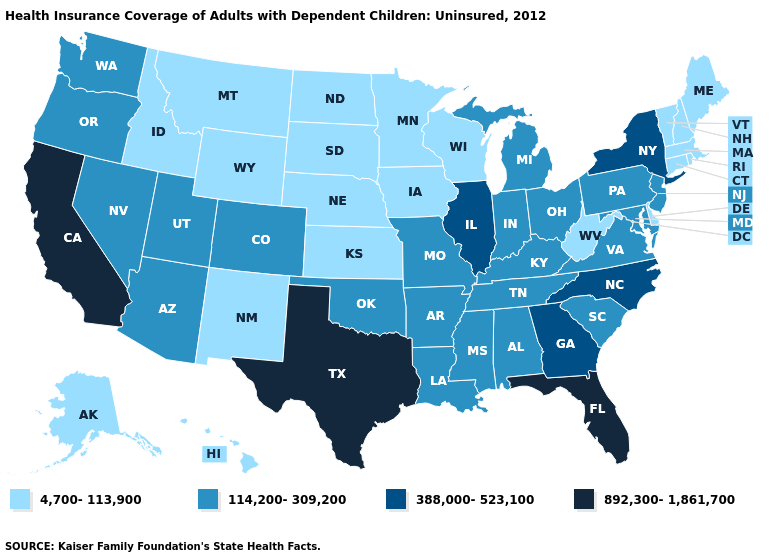Does New Hampshire have the lowest value in the USA?
Quick response, please. Yes. Which states have the lowest value in the USA?
Short answer required. Alaska, Connecticut, Delaware, Hawaii, Idaho, Iowa, Kansas, Maine, Massachusetts, Minnesota, Montana, Nebraska, New Hampshire, New Mexico, North Dakota, Rhode Island, South Dakota, Vermont, West Virginia, Wisconsin, Wyoming. Name the states that have a value in the range 114,200-309,200?
Write a very short answer. Alabama, Arizona, Arkansas, Colorado, Indiana, Kentucky, Louisiana, Maryland, Michigan, Mississippi, Missouri, Nevada, New Jersey, Ohio, Oklahoma, Oregon, Pennsylvania, South Carolina, Tennessee, Utah, Virginia, Washington. What is the lowest value in states that border New Jersey?
Quick response, please. 4,700-113,900. Name the states that have a value in the range 4,700-113,900?
Keep it brief. Alaska, Connecticut, Delaware, Hawaii, Idaho, Iowa, Kansas, Maine, Massachusetts, Minnesota, Montana, Nebraska, New Hampshire, New Mexico, North Dakota, Rhode Island, South Dakota, Vermont, West Virginia, Wisconsin, Wyoming. Does Mississippi have a higher value than South Dakota?
Answer briefly. Yes. What is the lowest value in the USA?
Quick response, please. 4,700-113,900. Name the states that have a value in the range 388,000-523,100?
Write a very short answer. Georgia, Illinois, New York, North Carolina. Name the states that have a value in the range 114,200-309,200?
Keep it brief. Alabama, Arizona, Arkansas, Colorado, Indiana, Kentucky, Louisiana, Maryland, Michigan, Mississippi, Missouri, Nevada, New Jersey, Ohio, Oklahoma, Oregon, Pennsylvania, South Carolina, Tennessee, Utah, Virginia, Washington. Does the first symbol in the legend represent the smallest category?
Concise answer only. Yes. Does Pennsylvania have the lowest value in the USA?
Answer briefly. No. Name the states that have a value in the range 4,700-113,900?
Quick response, please. Alaska, Connecticut, Delaware, Hawaii, Idaho, Iowa, Kansas, Maine, Massachusetts, Minnesota, Montana, Nebraska, New Hampshire, New Mexico, North Dakota, Rhode Island, South Dakota, Vermont, West Virginia, Wisconsin, Wyoming. Does Florida have the same value as California?
Give a very brief answer. Yes. Name the states that have a value in the range 388,000-523,100?
Answer briefly. Georgia, Illinois, New York, North Carolina. 